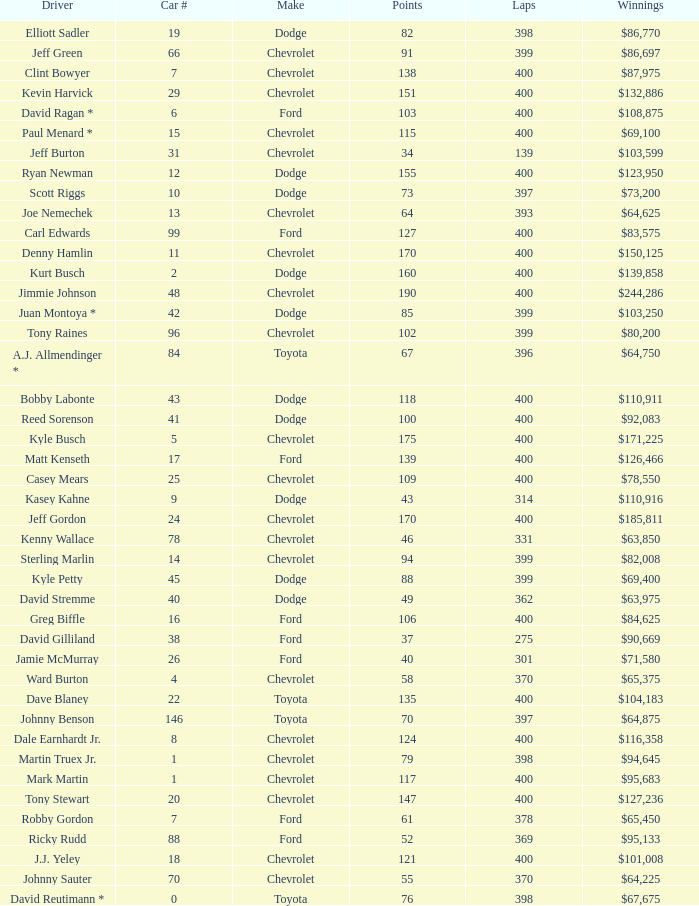What were the winnings for the Chevrolet with a number larger than 29 and scored 102 points? $80,200. 